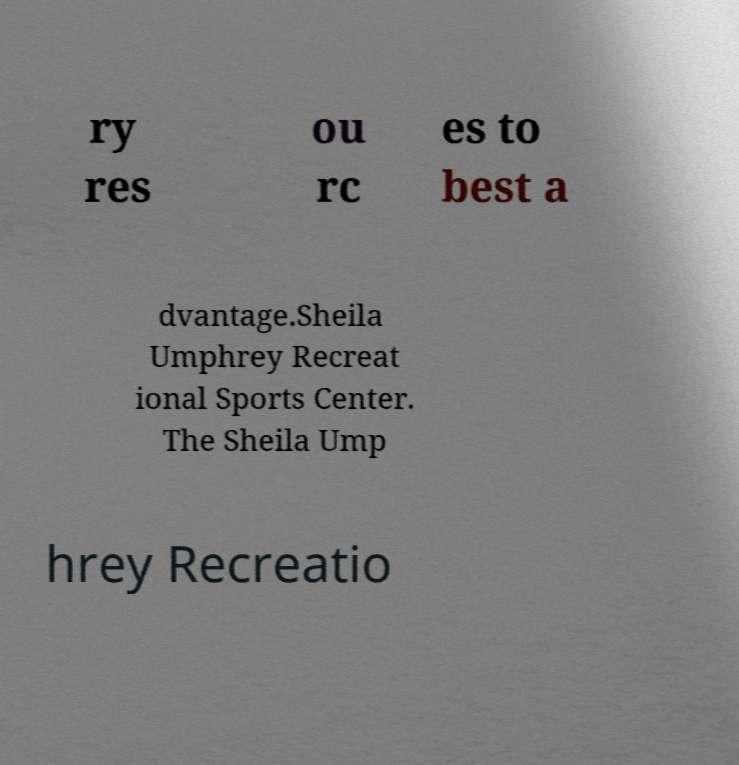There's text embedded in this image that I need extracted. Can you transcribe it verbatim? ry res ou rc es to best a dvantage.Sheila Umphrey Recreat ional Sports Center. The Sheila Ump hrey Recreatio 